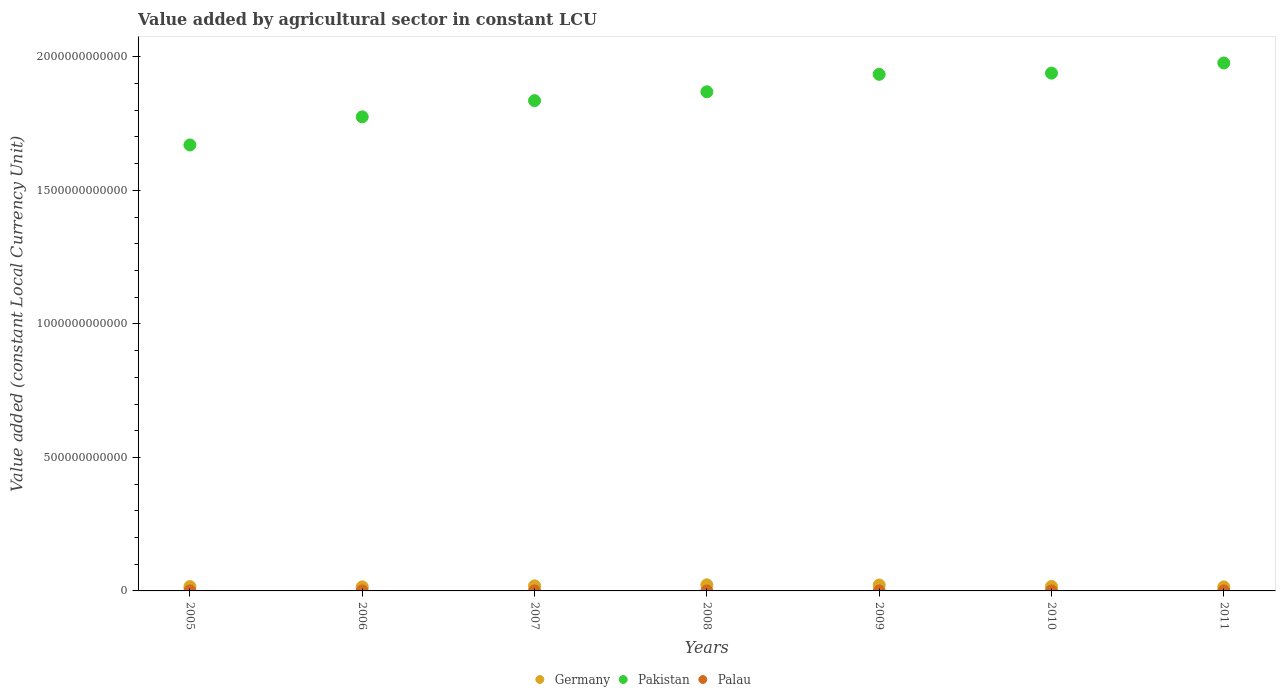How many different coloured dotlines are there?
Ensure brevity in your answer.  3. Is the number of dotlines equal to the number of legend labels?
Provide a short and direct response. Yes. What is the value added by agricultural sector in Pakistan in 2008?
Make the answer very short. 1.87e+12. Across all years, what is the maximum value added by agricultural sector in Palau?
Offer a very short reply. 8.27e+06. Across all years, what is the minimum value added by agricultural sector in Pakistan?
Provide a succinct answer. 1.67e+12. What is the total value added by agricultural sector in Germany in the graph?
Offer a very short reply. 1.27e+11. What is the difference between the value added by agricultural sector in Germany in 2005 and that in 2009?
Provide a succinct answer. -5.98e+09. What is the difference between the value added by agricultural sector in Pakistan in 2010 and the value added by agricultural sector in Germany in 2009?
Offer a terse response. 1.92e+12. What is the average value added by agricultural sector in Pakistan per year?
Provide a succinct answer. 1.86e+12. In the year 2005, what is the difference between the value added by agricultural sector in Palau and value added by agricultural sector in Germany?
Make the answer very short. -1.61e+1. What is the ratio of the value added by agricultural sector in Germany in 2005 to that in 2009?
Your answer should be very brief. 0.73. Is the difference between the value added by agricultural sector in Palau in 2008 and 2009 greater than the difference between the value added by agricultural sector in Germany in 2008 and 2009?
Your response must be concise. No. What is the difference between the highest and the second highest value added by agricultural sector in Pakistan?
Make the answer very short. 3.80e+1. What is the difference between the highest and the lowest value added by agricultural sector in Palau?
Ensure brevity in your answer.  1.63e+06. In how many years, is the value added by agricultural sector in Palau greater than the average value added by agricultural sector in Palau taken over all years?
Ensure brevity in your answer.  4. Does the value added by agricultural sector in Germany monotonically increase over the years?
Offer a terse response. No. Is the value added by agricultural sector in Germany strictly greater than the value added by agricultural sector in Pakistan over the years?
Offer a terse response. No. Is the value added by agricultural sector in Palau strictly less than the value added by agricultural sector in Pakistan over the years?
Provide a succinct answer. Yes. What is the difference between two consecutive major ticks on the Y-axis?
Offer a very short reply. 5.00e+11. Does the graph contain grids?
Offer a terse response. No. What is the title of the graph?
Offer a terse response. Value added by agricultural sector in constant LCU. Does "Small states" appear as one of the legend labels in the graph?
Provide a short and direct response. No. What is the label or title of the X-axis?
Your answer should be very brief. Years. What is the label or title of the Y-axis?
Provide a short and direct response. Value added (constant Local Currency Unit). What is the Value added (constant Local Currency Unit) in Germany in 2005?
Provide a succinct answer. 1.61e+1. What is the Value added (constant Local Currency Unit) of Pakistan in 2005?
Ensure brevity in your answer.  1.67e+12. What is the Value added (constant Local Currency Unit) in Palau in 2005?
Provide a succinct answer. 7.64e+06. What is the Value added (constant Local Currency Unit) of Germany in 2006?
Provide a short and direct response. 1.52e+1. What is the Value added (constant Local Currency Unit) of Pakistan in 2006?
Make the answer very short. 1.78e+12. What is the Value added (constant Local Currency Unit) of Palau in 2006?
Offer a very short reply. 8.27e+06. What is the Value added (constant Local Currency Unit) of Germany in 2007?
Offer a very short reply. 1.90e+1. What is the Value added (constant Local Currency Unit) in Pakistan in 2007?
Provide a short and direct response. 1.84e+12. What is the Value added (constant Local Currency Unit) of Palau in 2007?
Offer a very short reply. 7.64e+06. What is the Value added (constant Local Currency Unit) in Germany in 2008?
Your answer should be compact. 2.28e+1. What is the Value added (constant Local Currency Unit) in Pakistan in 2008?
Ensure brevity in your answer.  1.87e+12. What is the Value added (constant Local Currency Unit) in Palau in 2008?
Give a very brief answer. 7.84e+06. What is the Value added (constant Local Currency Unit) in Germany in 2009?
Provide a succinct answer. 2.21e+1. What is the Value added (constant Local Currency Unit) of Pakistan in 2009?
Give a very brief answer. 1.93e+12. What is the Value added (constant Local Currency Unit) in Palau in 2009?
Provide a succinct answer. 7.00e+06. What is the Value added (constant Local Currency Unit) in Germany in 2010?
Your response must be concise. 1.67e+1. What is the Value added (constant Local Currency Unit) of Pakistan in 2010?
Offer a terse response. 1.94e+12. What is the Value added (constant Local Currency Unit) in Palau in 2010?
Offer a terse response. 6.64e+06. What is the Value added (constant Local Currency Unit) in Germany in 2011?
Ensure brevity in your answer.  1.50e+1. What is the Value added (constant Local Currency Unit) in Pakistan in 2011?
Your answer should be compact. 1.98e+12. What is the Value added (constant Local Currency Unit) of Palau in 2011?
Keep it short and to the point. 7.28e+06. Across all years, what is the maximum Value added (constant Local Currency Unit) of Germany?
Keep it short and to the point. 2.28e+1. Across all years, what is the maximum Value added (constant Local Currency Unit) of Pakistan?
Provide a succinct answer. 1.98e+12. Across all years, what is the maximum Value added (constant Local Currency Unit) in Palau?
Make the answer very short. 8.27e+06. Across all years, what is the minimum Value added (constant Local Currency Unit) of Germany?
Your answer should be compact. 1.50e+1. Across all years, what is the minimum Value added (constant Local Currency Unit) of Pakistan?
Give a very brief answer. 1.67e+12. Across all years, what is the minimum Value added (constant Local Currency Unit) in Palau?
Ensure brevity in your answer.  6.64e+06. What is the total Value added (constant Local Currency Unit) of Germany in the graph?
Keep it short and to the point. 1.27e+11. What is the total Value added (constant Local Currency Unit) in Pakistan in the graph?
Keep it short and to the point. 1.30e+13. What is the total Value added (constant Local Currency Unit) in Palau in the graph?
Your response must be concise. 5.23e+07. What is the difference between the Value added (constant Local Currency Unit) of Germany in 2005 and that in 2006?
Ensure brevity in your answer.  9.57e+08. What is the difference between the Value added (constant Local Currency Unit) in Pakistan in 2005 and that in 2006?
Your answer should be compact. -1.05e+11. What is the difference between the Value added (constant Local Currency Unit) of Palau in 2005 and that in 2006?
Make the answer very short. -6.36e+05. What is the difference between the Value added (constant Local Currency Unit) in Germany in 2005 and that in 2007?
Make the answer very short. -2.90e+09. What is the difference between the Value added (constant Local Currency Unit) of Pakistan in 2005 and that in 2007?
Offer a very short reply. -1.66e+11. What is the difference between the Value added (constant Local Currency Unit) in Palau in 2005 and that in 2007?
Provide a succinct answer. 778.28. What is the difference between the Value added (constant Local Currency Unit) in Germany in 2005 and that in 2008?
Make the answer very short. -6.72e+09. What is the difference between the Value added (constant Local Currency Unit) in Pakistan in 2005 and that in 2008?
Provide a succinct answer. -1.99e+11. What is the difference between the Value added (constant Local Currency Unit) of Palau in 2005 and that in 2008?
Offer a terse response. -2.02e+05. What is the difference between the Value added (constant Local Currency Unit) in Germany in 2005 and that in 2009?
Your answer should be compact. -5.98e+09. What is the difference between the Value added (constant Local Currency Unit) in Pakistan in 2005 and that in 2009?
Provide a succinct answer. -2.65e+11. What is the difference between the Value added (constant Local Currency Unit) of Palau in 2005 and that in 2009?
Offer a very short reply. 6.42e+05. What is the difference between the Value added (constant Local Currency Unit) in Germany in 2005 and that in 2010?
Provide a short and direct response. -5.91e+08. What is the difference between the Value added (constant Local Currency Unit) in Pakistan in 2005 and that in 2010?
Provide a short and direct response. -2.69e+11. What is the difference between the Value added (constant Local Currency Unit) in Palau in 2005 and that in 2010?
Make the answer very short. 9.94e+05. What is the difference between the Value added (constant Local Currency Unit) in Germany in 2005 and that in 2011?
Keep it short and to the point. 1.13e+09. What is the difference between the Value added (constant Local Currency Unit) of Pakistan in 2005 and that in 2011?
Offer a terse response. -3.07e+11. What is the difference between the Value added (constant Local Currency Unit) of Palau in 2005 and that in 2011?
Offer a very short reply. 3.62e+05. What is the difference between the Value added (constant Local Currency Unit) of Germany in 2006 and that in 2007?
Provide a short and direct response. -3.86e+09. What is the difference between the Value added (constant Local Currency Unit) of Pakistan in 2006 and that in 2007?
Your answer should be compact. -6.08e+1. What is the difference between the Value added (constant Local Currency Unit) of Palau in 2006 and that in 2007?
Make the answer very short. 6.37e+05. What is the difference between the Value added (constant Local Currency Unit) of Germany in 2006 and that in 2008?
Provide a succinct answer. -7.68e+09. What is the difference between the Value added (constant Local Currency Unit) of Pakistan in 2006 and that in 2008?
Your answer should be compact. -9.40e+1. What is the difference between the Value added (constant Local Currency Unit) in Palau in 2006 and that in 2008?
Keep it short and to the point. 4.34e+05. What is the difference between the Value added (constant Local Currency Unit) of Germany in 2006 and that in 2009?
Your answer should be compact. -6.93e+09. What is the difference between the Value added (constant Local Currency Unit) in Pakistan in 2006 and that in 2009?
Offer a very short reply. -1.59e+11. What is the difference between the Value added (constant Local Currency Unit) of Palau in 2006 and that in 2009?
Make the answer very short. 1.28e+06. What is the difference between the Value added (constant Local Currency Unit) in Germany in 2006 and that in 2010?
Provide a short and direct response. -1.55e+09. What is the difference between the Value added (constant Local Currency Unit) in Pakistan in 2006 and that in 2010?
Ensure brevity in your answer.  -1.64e+11. What is the difference between the Value added (constant Local Currency Unit) of Palau in 2006 and that in 2010?
Offer a very short reply. 1.63e+06. What is the difference between the Value added (constant Local Currency Unit) of Germany in 2006 and that in 2011?
Your answer should be very brief. 1.75e+08. What is the difference between the Value added (constant Local Currency Unit) of Pakistan in 2006 and that in 2011?
Provide a succinct answer. -2.02e+11. What is the difference between the Value added (constant Local Currency Unit) in Palau in 2006 and that in 2011?
Ensure brevity in your answer.  9.98e+05. What is the difference between the Value added (constant Local Currency Unit) in Germany in 2007 and that in 2008?
Keep it short and to the point. -3.82e+09. What is the difference between the Value added (constant Local Currency Unit) in Pakistan in 2007 and that in 2008?
Your response must be concise. -3.32e+1. What is the difference between the Value added (constant Local Currency Unit) in Palau in 2007 and that in 2008?
Offer a terse response. -2.03e+05. What is the difference between the Value added (constant Local Currency Unit) of Germany in 2007 and that in 2009?
Provide a succinct answer. -3.07e+09. What is the difference between the Value added (constant Local Currency Unit) of Pakistan in 2007 and that in 2009?
Make the answer very short. -9.86e+1. What is the difference between the Value added (constant Local Currency Unit) of Palau in 2007 and that in 2009?
Make the answer very short. 6.41e+05. What is the difference between the Value added (constant Local Currency Unit) in Germany in 2007 and that in 2010?
Keep it short and to the point. 2.31e+09. What is the difference between the Value added (constant Local Currency Unit) of Pakistan in 2007 and that in 2010?
Your answer should be compact. -1.03e+11. What is the difference between the Value added (constant Local Currency Unit) of Palau in 2007 and that in 2010?
Your answer should be compact. 9.94e+05. What is the difference between the Value added (constant Local Currency Unit) of Germany in 2007 and that in 2011?
Your answer should be compact. 4.03e+09. What is the difference between the Value added (constant Local Currency Unit) of Pakistan in 2007 and that in 2011?
Give a very brief answer. -1.41e+11. What is the difference between the Value added (constant Local Currency Unit) of Palau in 2007 and that in 2011?
Make the answer very short. 3.61e+05. What is the difference between the Value added (constant Local Currency Unit) in Germany in 2008 and that in 2009?
Keep it short and to the point. 7.46e+08. What is the difference between the Value added (constant Local Currency Unit) of Pakistan in 2008 and that in 2009?
Make the answer very short. -6.54e+1. What is the difference between the Value added (constant Local Currency Unit) in Palau in 2008 and that in 2009?
Keep it short and to the point. 8.44e+05. What is the difference between the Value added (constant Local Currency Unit) in Germany in 2008 and that in 2010?
Ensure brevity in your answer.  6.13e+09. What is the difference between the Value added (constant Local Currency Unit) of Pakistan in 2008 and that in 2010?
Provide a succinct answer. -6.98e+1. What is the difference between the Value added (constant Local Currency Unit) of Palau in 2008 and that in 2010?
Give a very brief answer. 1.20e+06. What is the difference between the Value added (constant Local Currency Unit) in Germany in 2008 and that in 2011?
Provide a succinct answer. 7.85e+09. What is the difference between the Value added (constant Local Currency Unit) in Pakistan in 2008 and that in 2011?
Ensure brevity in your answer.  -1.08e+11. What is the difference between the Value added (constant Local Currency Unit) of Palau in 2008 and that in 2011?
Keep it short and to the point. 5.64e+05. What is the difference between the Value added (constant Local Currency Unit) in Germany in 2009 and that in 2010?
Your answer should be compact. 5.38e+09. What is the difference between the Value added (constant Local Currency Unit) of Pakistan in 2009 and that in 2010?
Ensure brevity in your answer.  -4.44e+09. What is the difference between the Value added (constant Local Currency Unit) of Palau in 2009 and that in 2010?
Provide a short and direct response. 3.53e+05. What is the difference between the Value added (constant Local Currency Unit) of Germany in 2009 and that in 2011?
Ensure brevity in your answer.  7.11e+09. What is the difference between the Value added (constant Local Currency Unit) in Pakistan in 2009 and that in 2011?
Offer a terse response. -4.25e+1. What is the difference between the Value added (constant Local Currency Unit) in Palau in 2009 and that in 2011?
Your answer should be compact. -2.80e+05. What is the difference between the Value added (constant Local Currency Unit) in Germany in 2010 and that in 2011?
Ensure brevity in your answer.  1.72e+09. What is the difference between the Value added (constant Local Currency Unit) in Pakistan in 2010 and that in 2011?
Make the answer very short. -3.80e+1. What is the difference between the Value added (constant Local Currency Unit) of Palau in 2010 and that in 2011?
Offer a terse response. -6.32e+05. What is the difference between the Value added (constant Local Currency Unit) in Germany in 2005 and the Value added (constant Local Currency Unit) in Pakistan in 2006?
Provide a succinct answer. -1.76e+12. What is the difference between the Value added (constant Local Currency Unit) in Germany in 2005 and the Value added (constant Local Currency Unit) in Palau in 2006?
Give a very brief answer. 1.61e+1. What is the difference between the Value added (constant Local Currency Unit) of Pakistan in 2005 and the Value added (constant Local Currency Unit) of Palau in 2006?
Provide a succinct answer. 1.67e+12. What is the difference between the Value added (constant Local Currency Unit) of Germany in 2005 and the Value added (constant Local Currency Unit) of Pakistan in 2007?
Your answer should be compact. -1.82e+12. What is the difference between the Value added (constant Local Currency Unit) in Germany in 2005 and the Value added (constant Local Currency Unit) in Palau in 2007?
Your answer should be compact. 1.61e+1. What is the difference between the Value added (constant Local Currency Unit) in Pakistan in 2005 and the Value added (constant Local Currency Unit) in Palau in 2007?
Your answer should be very brief. 1.67e+12. What is the difference between the Value added (constant Local Currency Unit) in Germany in 2005 and the Value added (constant Local Currency Unit) in Pakistan in 2008?
Ensure brevity in your answer.  -1.85e+12. What is the difference between the Value added (constant Local Currency Unit) in Germany in 2005 and the Value added (constant Local Currency Unit) in Palau in 2008?
Ensure brevity in your answer.  1.61e+1. What is the difference between the Value added (constant Local Currency Unit) in Pakistan in 2005 and the Value added (constant Local Currency Unit) in Palau in 2008?
Your answer should be compact. 1.67e+12. What is the difference between the Value added (constant Local Currency Unit) in Germany in 2005 and the Value added (constant Local Currency Unit) in Pakistan in 2009?
Keep it short and to the point. -1.92e+12. What is the difference between the Value added (constant Local Currency Unit) of Germany in 2005 and the Value added (constant Local Currency Unit) of Palau in 2009?
Keep it short and to the point. 1.61e+1. What is the difference between the Value added (constant Local Currency Unit) of Pakistan in 2005 and the Value added (constant Local Currency Unit) of Palau in 2009?
Give a very brief answer. 1.67e+12. What is the difference between the Value added (constant Local Currency Unit) of Germany in 2005 and the Value added (constant Local Currency Unit) of Pakistan in 2010?
Provide a short and direct response. -1.92e+12. What is the difference between the Value added (constant Local Currency Unit) in Germany in 2005 and the Value added (constant Local Currency Unit) in Palau in 2010?
Give a very brief answer. 1.61e+1. What is the difference between the Value added (constant Local Currency Unit) of Pakistan in 2005 and the Value added (constant Local Currency Unit) of Palau in 2010?
Your response must be concise. 1.67e+12. What is the difference between the Value added (constant Local Currency Unit) in Germany in 2005 and the Value added (constant Local Currency Unit) in Pakistan in 2011?
Your answer should be compact. -1.96e+12. What is the difference between the Value added (constant Local Currency Unit) of Germany in 2005 and the Value added (constant Local Currency Unit) of Palau in 2011?
Give a very brief answer. 1.61e+1. What is the difference between the Value added (constant Local Currency Unit) in Pakistan in 2005 and the Value added (constant Local Currency Unit) in Palau in 2011?
Your answer should be very brief. 1.67e+12. What is the difference between the Value added (constant Local Currency Unit) of Germany in 2006 and the Value added (constant Local Currency Unit) of Pakistan in 2007?
Your answer should be compact. -1.82e+12. What is the difference between the Value added (constant Local Currency Unit) of Germany in 2006 and the Value added (constant Local Currency Unit) of Palau in 2007?
Provide a short and direct response. 1.51e+1. What is the difference between the Value added (constant Local Currency Unit) in Pakistan in 2006 and the Value added (constant Local Currency Unit) in Palau in 2007?
Your response must be concise. 1.78e+12. What is the difference between the Value added (constant Local Currency Unit) in Germany in 2006 and the Value added (constant Local Currency Unit) in Pakistan in 2008?
Offer a terse response. -1.85e+12. What is the difference between the Value added (constant Local Currency Unit) in Germany in 2006 and the Value added (constant Local Currency Unit) in Palau in 2008?
Offer a very short reply. 1.51e+1. What is the difference between the Value added (constant Local Currency Unit) in Pakistan in 2006 and the Value added (constant Local Currency Unit) in Palau in 2008?
Keep it short and to the point. 1.78e+12. What is the difference between the Value added (constant Local Currency Unit) of Germany in 2006 and the Value added (constant Local Currency Unit) of Pakistan in 2009?
Give a very brief answer. -1.92e+12. What is the difference between the Value added (constant Local Currency Unit) of Germany in 2006 and the Value added (constant Local Currency Unit) of Palau in 2009?
Make the answer very short. 1.51e+1. What is the difference between the Value added (constant Local Currency Unit) of Pakistan in 2006 and the Value added (constant Local Currency Unit) of Palau in 2009?
Provide a short and direct response. 1.78e+12. What is the difference between the Value added (constant Local Currency Unit) of Germany in 2006 and the Value added (constant Local Currency Unit) of Pakistan in 2010?
Your response must be concise. -1.92e+12. What is the difference between the Value added (constant Local Currency Unit) of Germany in 2006 and the Value added (constant Local Currency Unit) of Palau in 2010?
Offer a very short reply. 1.51e+1. What is the difference between the Value added (constant Local Currency Unit) of Pakistan in 2006 and the Value added (constant Local Currency Unit) of Palau in 2010?
Offer a very short reply. 1.78e+12. What is the difference between the Value added (constant Local Currency Unit) of Germany in 2006 and the Value added (constant Local Currency Unit) of Pakistan in 2011?
Provide a short and direct response. -1.96e+12. What is the difference between the Value added (constant Local Currency Unit) of Germany in 2006 and the Value added (constant Local Currency Unit) of Palau in 2011?
Ensure brevity in your answer.  1.51e+1. What is the difference between the Value added (constant Local Currency Unit) of Pakistan in 2006 and the Value added (constant Local Currency Unit) of Palau in 2011?
Give a very brief answer. 1.78e+12. What is the difference between the Value added (constant Local Currency Unit) of Germany in 2007 and the Value added (constant Local Currency Unit) of Pakistan in 2008?
Offer a terse response. -1.85e+12. What is the difference between the Value added (constant Local Currency Unit) of Germany in 2007 and the Value added (constant Local Currency Unit) of Palau in 2008?
Offer a terse response. 1.90e+1. What is the difference between the Value added (constant Local Currency Unit) in Pakistan in 2007 and the Value added (constant Local Currency Unit) in Palau in 2008?
Offer a terse response. 1.84e+12. What is the difference between the Value added (constant Local Currency Unit) in Germany in 2007 and the Value added (constant Local Currency Unit) in Pakistan in 2009?
Provide a short and direct response. -1.92e+12. What is the difference between the Value added (constant Local Currency Unit) of Germany in 2007 and the Value added (constant Local Currency Unit) of Palau in 2009?
Provide a succinct answer. 1.90e+1. What is the difference between the Value added (constant Local Currency Unit) of Pakistan in 2007 and the Value added (constant Local Currency Unit) of Palau in 2009?
Offer a very short reply. 1.84e+12. What is the difference between the Value added (constant Local Currency Unit) in Germany in 2007 and the Value added (constant Local Currency Unit) in Pakistan in 2010?
Ensure brevity in your answer.  -1.92e+12. What is the difference between the Value added (constant Local Currency Unit) of Germany in 2007 and the Value added (constant Local Currency Unit) of Palau in 2010?
Ensure brevity in your answer.  1.90e+1. What is the difference between the Value added (constant Local Currency Unit) in Pakistan in 2007 and the Value added (constant Local Currency Unit) in Palau in 2010?
Provide a short and direct response. 1.84e+12. What is the difference between the Value added (constant Local Currency Unit) of Germany in 2007 and the Value added (constant Local Currency Unit) of Pakistan in 2011?
Your answer should be very brief. -1.96e+12. What is the difference between the Value added (constant Local Currency Unit) in Germany in 2007 and the Value added (constant Local Currency Unit) in Palau in 2011?
Your answer should be very brief. 1.90e+1. What is the difference between the Value added (constant Local Currency Unit) of Pakistan in 2007 and the Value added (constant Local Currency Unit) of Palau in 2011?
Keep it short and to the point. 1.84e+12. What is the difference between the Value added (constant Local Currency Unit) in Germany in 2008 and the Value added (constant Local Currency Unit) in Pakistan in 2009?
Your answer should be compact. -1.91e+12. What is the difference between the Value added (constant Local Currency Unit) in Germany in 2008 and the Value added (constant Local Currency Unit) in Palau in 2009?
Your response must be concise. 2.28e+1. What is the difference between the Value added (constant Local Currency Unit) in Pakistan in 2008 and the Value added (constant Local Currency Unit) in Palau in 2009?
Give a very brief answer. 1.87e+12. What is the difference between the Value added (constant Local Currency Unit) in Germany in 2008 and the Value added (constant Local Currency Unit) in Pakistan in 2010?
Ensure brevity in your answer.  -1.92e+12. What is the difference between the Value added (constant Local Currency Unit) in Germany in 2008 and the Value added (constant Local Currency Unit) in Palau in 2010?
Give a very brief answer. 2.28e+1. What is the difference between the Value added (constant Local Currency Unit) of Pakistan in 2008 and the Value added (constant Local Currency Unit) of Palau in 2010?
Offer a terse response. 1.87e+12. What is the difference between the Value added (constant Local Currency Unit) in Germany in 2008 and the Value added (constant Local Currency Unit) in Pakistan in 2011?
Provide a short and direct response. -1.95e+12. What is the difference between the Value added (constant Local Currency Unit) in Germany in 2008 and the Value added (constant Local Currency Unit) in Palau in 2011?
Offer a terse response. 2.28e+1. What is the difference between the Value added (constant Local Currency Unit) in Pakistan in 2008 and the Value added (constant Local Currency Unit) in Palau in 2011?
Ensure brevity in your answer.  1.87e+12. What is the difference between the Value added (constant Local Currency Unit) in Germany in 2009 and the Value added (constant Local Currency Unit) in Pakistan in 2010?
Offer a terse response. -1.92e+12. What is the difference between the Value added (constant Local Currency Unit) in Germany in 2009 and the Value added (constant Local Currency Unit) in Palau in 2010?
Ensure brevity in your answer.  2.21e+1. What is the difference between the Value added (constant Local Currency Unit) of Pakistan in 2009 and the Value added (constant Local Currency Unit) of Palau in 2010?
Your answer should be compact. 1.93e+12. What is the difference between the Value added (constant Local Currency Unit) of Germany in 2009 and the Value added (constant Local Currency Unit) of Pakistan in 2011?
Keep it short and to the point. -1.96e+12. What is the difference between the Value added (constant Local Currency Unit) in Germany in 2009 and the Value added (constant Local Currency Unit) in Palau in 2011?
Ensure brevity in your answer.  2.21e+1. What is the difference between the Value added (constant Local Currency Unit) in Pakistan in 2009 and the Value added (constant Local Currency Unit) in Palau in 2011?
Make the answer very short. 1.93e+12. What is the difference between the Value added (constant Local Currency Unit) in Germany in 2010 and the Value added (constant Local Currency Unit) in Pakistan in 2011?
Provide a succinct answer. -1.96e+12. What is the difference between the Value added (constant Local Currency Unit) in Germany in 2010 and the Value added (constant Local Currency Unit) in Palau in 2011?
Give a very brief answer. 1.67e+1. What is the difference between the Value added (constant Local Currency Unit) of Pakistan in 2010 and the Value added (constant Local Currency Unit) of Palau in 2011?
Provide a succinct answer. 1.94e+12. What is the average Value added (constant Local Currency Unit) of Germany per year?
Offer a very short reply. 1.81e+1. What is the average Value added (constant Local Currency Unit) in Pakistan per year?
Give a very brief answer. 1.86e+12. What is the average Value added (constant Local Currency Unit) in Palau per year?
Offer a very short reply. 7.47e+06. In the year 2005, what is the difference between the Value added (constant Local Currency Unit) of Germany and Value added (constant Local Currency Unit) of Pakistan?
Your response must be concise. -1.65e+12. In the year 2005, what is the difference between the Value added (constant Local Currency Unit) of Germany and Value added (constant Local Currency Unit) of Palau?
Ensure brevity in your answer.  1.61e+1. In the year 2005, what is the difference between the Value added (constant Local Currency Unit) of Pakistan and Value added (constant Local Currency Unit) of Palau?
Your answer should be very brief. 1.67e+12. In the year 2006, what is the difference between the Value added (constant Local Currency Unit) in Germany and Value added (constant Local Currency Unit) in Pakistan?
Offer a terse response. -1.76e+12. In the year 2006, what is the difference between the Value added (constant Local Currency Unit) in Germany and Value added (constant Local Currency Unit) in Palau?
Make the answer very short. 1.51e+1. In the year 2006, what is the difference between the Value added (constant Local Currency Unit) of Pakistan and Value added (constant Local Currency Unit) of Palau?
Give a very brief answer. 1.78e+12. In the year 2007, what is the difference between the Value added (constant Local Currency Unit) of Germany and Value added (constant Local Currency Unit) of Pakistan?
Provide a succinct answer. -1.82e+12. In the year 2007, what is the difference between the Value added (constant Local Currency Unit) of Germany and Value added (constant Local Currency Unit) of Palau?
Offer a terse response. 1.90e+1. In the year 2007, what is the difference between the Value added (constant Local Currency Unit) in Pakistan and Value added (constant Local Currency Unit) in Palau?
Offer a very short reply. 1.84e+12. In the year 2008, what is the difference between the Value added (constant Local Currency Unit) of Germany and Value added (constant Local Currency Unit) of Pakistan?
Give a very brief answer. -1.85e+12. In the year 2008, what is the difference between the Value added (constant Local Currency Unit) of Germany and Value added (constant Local Currency Unit) of Palau?
Keep it short and to the point. 2.28e+1. In the year 2008, what is the difference between the Value added (constant Local Currency Unit) of Pakistan and Value added (constant Local Currency Unit) of Palau?
Your answer should be very brief. 1.87e+12. In the year 2009, what is the difference between the Value added (constant Local Currency Unit) of Germany and Value added (constant Local Currency Unit) of Pakistan?
Provide a succinct answer. -1.91e+12. In the year 2009, what is the difference between the Value added (constant Local Currency Unit) in Germany and Value added (constant Local Currency Unit) in Palau?
Provide a succinct answer. 2.21e+1. In the year 2009, what is the difference between the Value added (constant Local Currency Unit) in Pakistan and Value added (constant Local Currency Unit) in Palau?
Keep it short and to the point. 1.93e+12. In the year 2010, what is the difference between the Value added (constant Local Currency Unit) of Germany and Value added (constant Local Currency Unit) of Pakistan?
Give a very brief answer. -1.92e+12. In the year 2010, what is the difference between the Value added (constant Local Currency Unit) in Germany and Value added (constant Local Currency Unit) in Palau?
Your response must be concise. 1.67e+1. In the year 2010, what is the difference between the Value added (constant Local Currency Unit) in Pakistan and Value added (constant Local Currency Unit) in Palau?
Your answer should be compact. 1.94e+12. In the year 2011, what is the difference between the Value added (constant Local Currency Unit) of Germany and Value added (constant Local Currency Unit) of Pakistan?
Offer a very short reply. -1.96e+12. In the year 2011, what is the difference between the Value added (constant Local Currency Unit) in Germany and Value added (constant Local Currency Unit) in Palau?
Give a very brief answer. 1.50e+1. In the year 2011, what is the difference between the Value added (constant Local Currency Unit) in Pakistan and Value added (constant Local Currency Unit) in Palau?
Give a very brief answer. 1.98e+12. What is the ratio of the Value added (constant Local Currency Unit) of Germany in 2005 to that in 2006?
Your answer should be compact. 1.06. What is the ratio of the Value added (constant Local Currency Unit) in Pakistan in 2005 to that in 2006?
Your answer should be very brief. 0.94. What is the ratio of the Value added (constant Local Currency Unit) of Palau in 2005 to that in 2006?
Provide a succinct answer. 0.92. What is the ratio of the Value added (constant Local Currency Unit) in Germany in 2005 to that in 2007?
Your answer should be compact. 0.85. What is the ratio of the Value added (constant Local Currency Unit) in Pakistan in 2005 to that in 2007?
Ensure brevity in your answer.  0.91. What is the ratio of the Value added (constant Local Currency Unit) in Palau in 2005 to that in 2007?
Ensure brevity in your answer.  1. What is the ratio of the Value added (constant Local Currency Unit) in Germany in 2005 to that in 2008?
Provide a succinct answer. 0.71. What is the ratio of the Value added (constant Local Currency Unit) of Pakistan in 2005 to that in 2008?
Your answer should be compact. 0.89. What is the ratio of the Value added (constant Local Currency Unit) in Palau in 2005 to that in 2008?
Your answer should be very brief. 0.97. What is the ratio of the Value added (constant Local Currency Unit) in Germany in 2005 to that in 2009?
Your response must be concise. 0.73. What is the ratio of the Value added (constant Local Currency Unit) of Pakistan in 2005 to that in 2009?
Give a very brief answer. 0.86. What is the ratio of the Value added (constant Local Currency Unit) of Palau in 2005 to that in 2009?
Offer a very short reply. 1.09. What is the ratio of the Value added (constant Local Currency Unit) of Germany in 2005 to that in 2010?
Offer a terse response. 0.96. What is the ratio of the Value added (constant Local Currency Unit) of Pakistan in 2005 to that in 2010?
Ensure brevity in your answer.  0.86. What is the ratio of the Value added (constant Local Currency Unit) of Palau in 2005 to that in 2010?
Provide a succinct answer. 1.15. What is the ratio of the Value added (constant Local Currency Unit) in Germany in 2005 to that in 2011?
Offer a terse response. 1.08. What is the ratio of the Value added (constant Local Currency Unit) of Pakistan in 2005 to that in 2011?
Your answer should be compact. 0.84. What is the ratio of the Value added (constant Local Currency Unit) of Palau in 2005 to that in 2011?
Give a very brief answer. 1.05. What is the ratio of the Value added (constant Local Currency Unit) of Germany in 2006 to that in 2007?
Give a very brief answer. 0.8. What is the ratio of the Value added (constant Local Currency Unit) of Pakistan in 2006 to that in 2007?
Make the answer very short. 0.97. What is the ratio of the Value added (constant Local Currency Unit) of Germany in 2006 to that in 2008?
Offer a very short reply. 0.66. What is the ratio of the Value added (constant Local Currency Unit) of Pakistan in 2006 to that in 2008?
Offer a very short reply. 0.95. What is the ratio of the Value added (constant Local Currency Unit) in Palau in 2006 to that in 2008?
Offer a terse response. 1.06. What is the ratio of the Value added (constant Local Currency Unit) in Germany in 2006 to that in 2009?
Provide a succinct answer. 0.69. What is the ratio of the Value added (constant Local Currency Unit) of Pakistan in 2006 to that in 2009?
Provide a short and direct response. 0.92. What is the ratio of the Value added (constant Local Currency Unit) in Palau in 2006 to that in 2009?
Your answer should be compact. 1.18. What is the ratio of the Value added (constant Local Currency Unit) of Germany in 2006 to that in 2010?
Offer a terse response. 0.91. What is the ratio of the Value added (constant Local Currency Unit) in Pakistan in 2006 to that in 2010?
Keep it short and to the point. 0.92. What is the ratio of the Value added (constant Local Currency Unit) in Palau in 2006 to that in 2010?
Make the answer very short. 1.25. What is the ratio of the Value added (constant Local Currency Unit) in Germany in 2006 to that in 2011?
Make the answer very short. 1.01. What is the ratio of the Value added (constant Local Currency Unit) of Pakistan in 2006 to that in 2011?
Your answer should be very brief. 0.9. What is the ratio of the Value added (constant Local Currency Unit) of Palau in 2006 to that in 2011?
Provide a succinct answer. 1.14. What is the ratio of the Value added (constant Local Currency Unit) of Germany in 2007 to that in 2008?
Ensure brevity in your answer.  0.83. What is the ratio of the Value added (constant Local Currency Unit) of Pakistan in 2007 to that in 2008?
Ensure brevity in your answer.  0.98. What is the ratio of the Value added (constant Local Currency Unit) in Palau in 2007 to that in 2008?
Make the answer very short. 0.97. What is the ratio of the Value added (constant Local Currency Unit) of Germany in 2007 to that in 2009?
Ensure brevity in your answer.  0.86. What is the ratio of the Value added (constant Local Currency Unit) in Pakistan in 2007 to that in 2009?
Ensure brevity in your answer.  0.95. What is the ratio of the Value added (constant Local Currency Unit) in Palau in 2007 to that in 2009?
Offer a terse response. 1.09. What is the ratio of the Value added (constant Local Currency Unit) of Germany in 2007 to that in 2010?
Offer a terse response. 1.14. What is the ratio of the Value added (constant Local Currency Unit) of Pakistan in 2007 to that in 2010?
Offer a very short reply. 0.95. What is the ratio of the Value added (constant Local Currency Unit) in Palau in 2007 to that in 2010?
Your answer should be compact. 1.15. What is the ratio of the Value added (constant Local Currency Unit) of Germany in 2007 to that in 2011?
Provide a succinct answer. 1.27. What is the ratio of the Value added (constant Local Currency Unit) in Pakistan in 2007 to that in 2011?
Your answer should be compact. 0.93. What is the ratio of the Value added (constant Local Currency Unit) of Palau in 2007 to that in 2011?
Offer a terse response. 1.05. What is the ratio of the Value added (constant Local Currency Unit) of Germany in 2008 to that in 2009?
Make the answer very short. 1.03. What is the ratio of the Value added (constant Local Currency Unit) of Pakistan in 2008 to that in 2009?
Keep it short and to the point. 0.97. What is the ratio of the Value added (constant Local Currency Unit) in Palau in 2008 to that in 2009?
Provide a short and direct response. 1.12. What is the ratio of the Value added (constant Local Currency Unit) in Germany in 2008 to that in 2010?
Your answer should be very brief. 1.37. What is the ratio of the Value added (constant Local Currency Unit) in Palau in 2008 to that in 2010?
Make the answer very short. 1.18. What is the ratio of the Value added (constant Local Currency Unit) of Germany in 2008 to that in 2011?
Keep it short and to the point. 1.52. What is the ratio of the Value added (constant Local Currency Unit) in Pakistan in 2008 to that in 2011?
Your answer should be compact. 0.95. What is the ratio of the Value added (constant Local Currency Unit) of Palau in 2008 to that in 2011?
Your answer should be compact. 1.08. What is the ratio of the Value added (constant Local Currency Unit) of Germany in 2009 to that in 2010?
Your answer should be very brief. 1.32. What is the ratio of the Value added (constant Local Currency Unit) of Palau in 2009 to that in 2010?
Provide a succinct answer. 1.05. What is the ratio of the Value added (constant Local Currency Unit) in Germany in 2009 to that in 2011?
Ensure brevity in your answer.  1.47. What is the ratio of the Value added (constant Local Currency Unit) in Pakistan in 2009 to that in 2011?
Give a very brief answer. 0.98. What is the ratio of the Value added (constant Local Currency Unit) of Palau in 2009 to that in 2011?
Keep it short and to the point. 0.96. What is the ratio of the Value added (constant Local Currency Unit) of Germany in 2010 to that in 2011?
Keep it short and to the point. 1.12. What is the ratio of the Value added (constant Local Currency Unit) of Pakistan in 2010 to that in 2011?
Your response must be concise. 0.98. What is the ratio of the Value added (constant Local Currency Unit) of Palau in 2010 to that in 2011?
Your answer should be very brief. 0.91. What is the difference between the highest and the second highest Value added (constant Local Currency Unit) in Germany?
Your response must be concise. 7.46e+08. What is the difference between the highest and the second highest Value added (constant Local Currency Unit) in Pakistan?
Ensure brevity in your answer.  3.80e+1. What is the difference between the highest and the second highest Value added (constant Local Currency Unit) in Palau?
Your answer should be compact. 4.34e+05. What is the difference between the highest and the lowest Value added (constant Local Currency Unit) in Germany?
Offer a terse response. 7.85e+09. What is the difference between the highest and the lowest Value added (constant Local Currency Unit) in Pakistan?
Make the answer very short. 3.07e+11. What is the difference between the highest and the lowest Value added (constant Local Currency Unit) of Palau?
Keep it short and to the point. 1.63e+06. 